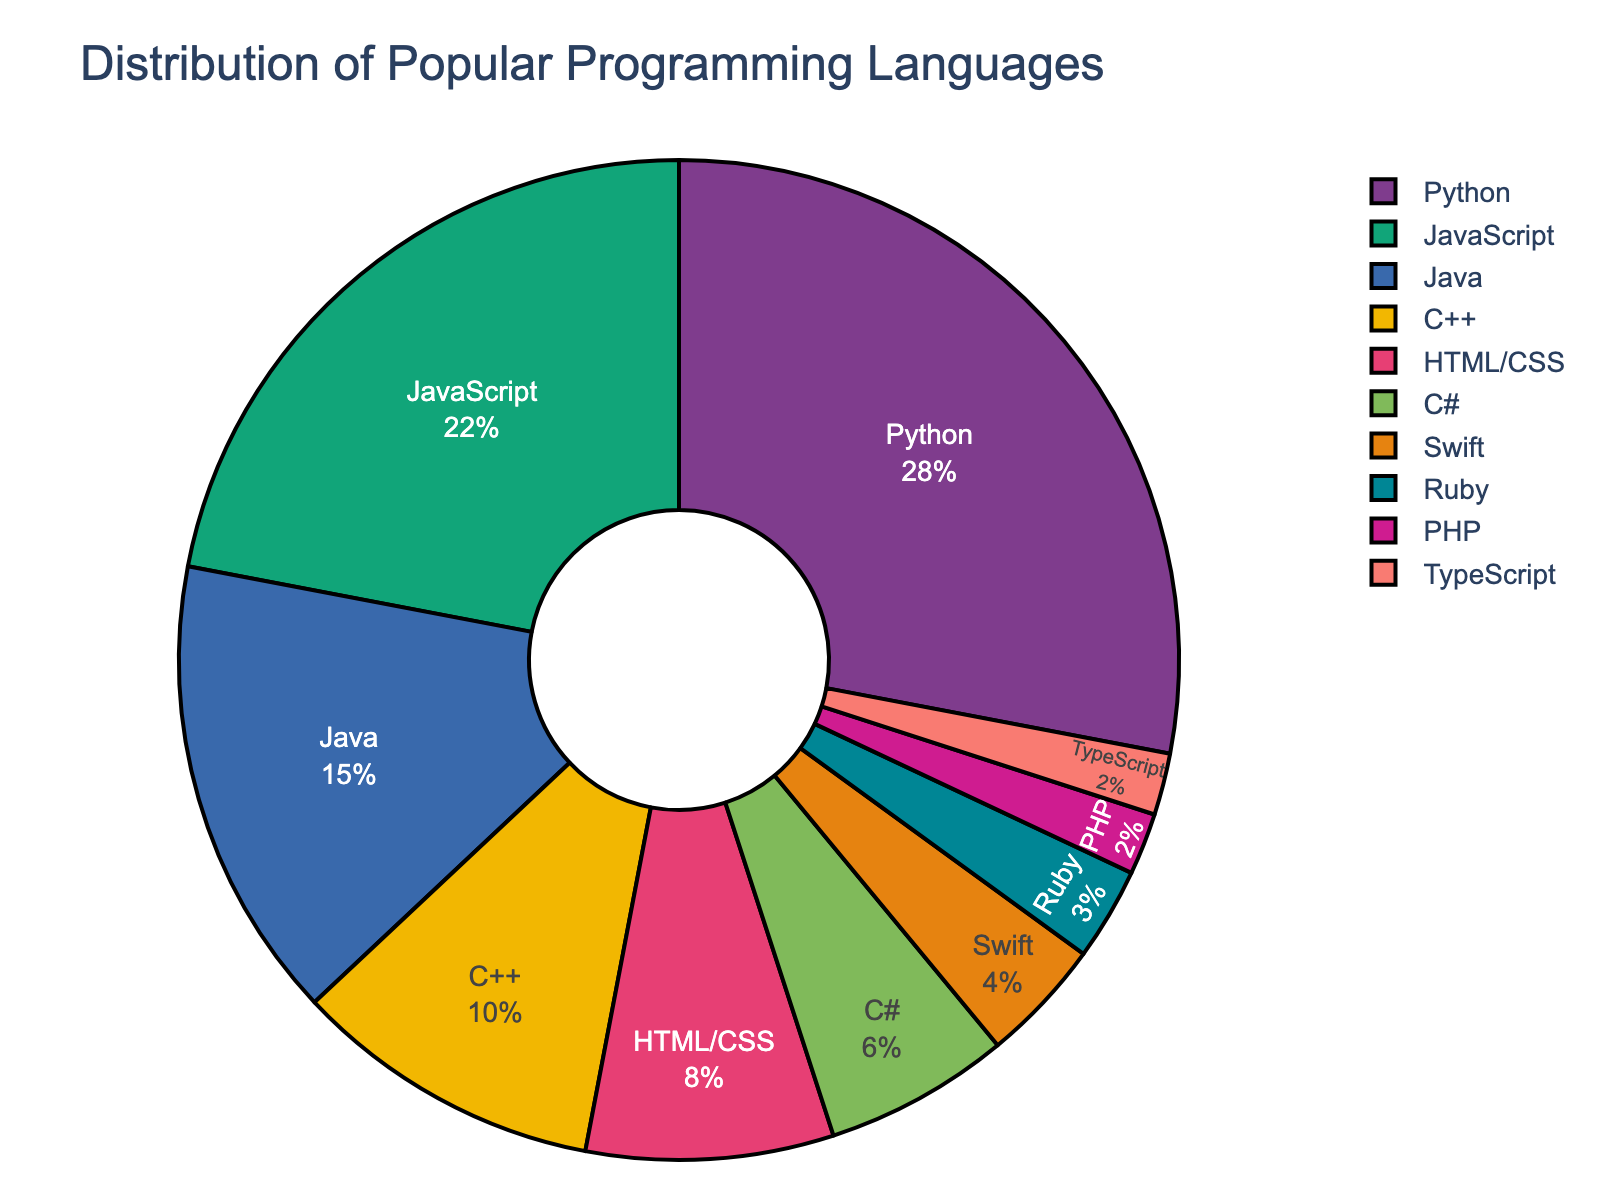Which programming language has the highest percentage among developers? The chart shows that Python has the largest slice of the pie, indicating it is the most popular language among developers with a percentage of 28%
Answer: Python What is the combined percentage of Java and C++? According to the chart, Java has a percentage of 15% and C++ has 10%. Adding these together gives 15% + 10% = 25%
Answer: 25% Which language is more popular, JavaScript or HTML/CSS? The chart shows that JavaScript has a larger slice of the pie with 22%, while HTML/CSS has 8%. Thus, JavaScript is more popular
Answer: JavaScript Is the percentage of Python users greater than the combined percentage of C# and Swift users? Python has a percentage of 28%. C# has 6% and Swift has 4%, so combined they have 6% + 4% = 10%. Since 28% is greater than 10%, Python's percentage is indeed larger
Answer: Yes What is the total percentage for all languages that have less than 5% share? The languages with less than 5% are Swift (4%), Ruby (3%), PHP (2%), and TypeScript (2%). Adding these together gives 4% + 3% + 2% + 2% = 11%
Answer: 11% Which language has the smallest representation among developers? The chart shows that TypeScript and PHP both have the smallest slices, with 2% each
Answer: TypeScript and PHP What is the difference in popularity between JavaScript and Java? JavaScript has a percentage of 22% and Java has 15%. The difference is 22% - 15% = 7%
Answer: 7% Are there more developers using Python or developers using both HTML/CSS and Ruby combined? Python has 28%. HTML/CSS has 8% and Ruby has 3%. Their combined percentage is 8% + 3% = 11%, while Python alone is 28%. Therefore, Python has more
Answer: Python What percentage of developers use a language that is not Python, JavaScript, or Java? Total percentage is 100%. Sum of Python (28%), JavaScript (22%), and Java (15%) is 28% + 22% + 15% = 65%. Subtracting this from 100% gives 100% - 65% = 35%
Answer: 35% How much more popular is Python than C#? Python's percentage is 28% and C#'s is 6%. The difference is 28% - 6% = 22%
Answer: 22% 